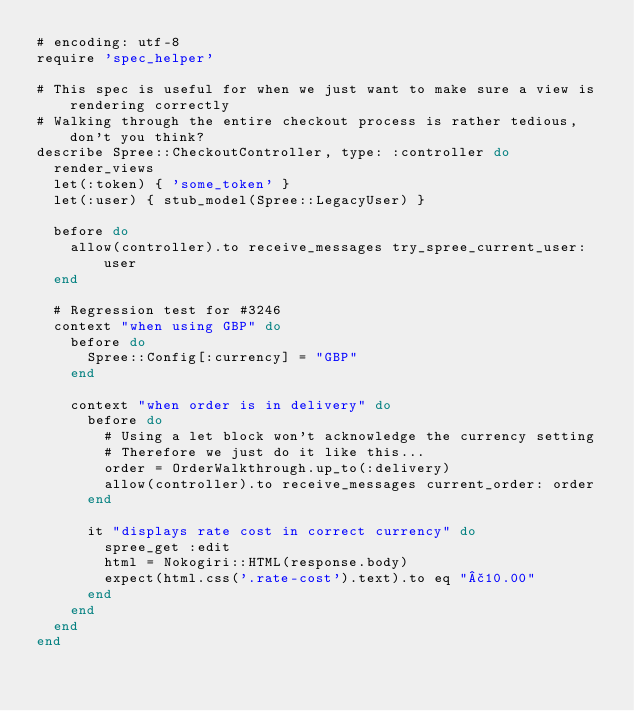Convert code to text. <code><loc_0><loc_0><loc_500><loc_500><_Ruby_># encoding: utf-8
require 'spec_helper'

# This spec is useful for when we just want to make sure a view is rendering correctly
# Walking through the entire checkout process is rather tedious, don't you think?
describe Spree::CheckoutController, type: :controller do
  render_views
  let(:token) { 'some_token' }
  let(:user) { stub_model(Spree::LegacyUser) }

  before do
    allow(controller).to receive_messages try_spree_current_user: user
  end

  # Regression test for #3246
  context "when using GBP" do
    before do
      Spree::Config[:currency] = "GBP"
    end

    context "when order is in delivery" do
      before do
        # Using a let block won't acknowledge the currency setting
        # Therefore we just do it like this...
        order = OrderWalkthrough.up_to(:delivery)
        allow(controller).to receive_messages current_order: order
      end

      it "displays rate cost in correct currency" do
        spree_get :edit
        html = Nokogiri::HTML(response.body)
        expect(html.css('.rate-cost').text).to eq "£10.00"
      end
    end
  end
end
</code> 